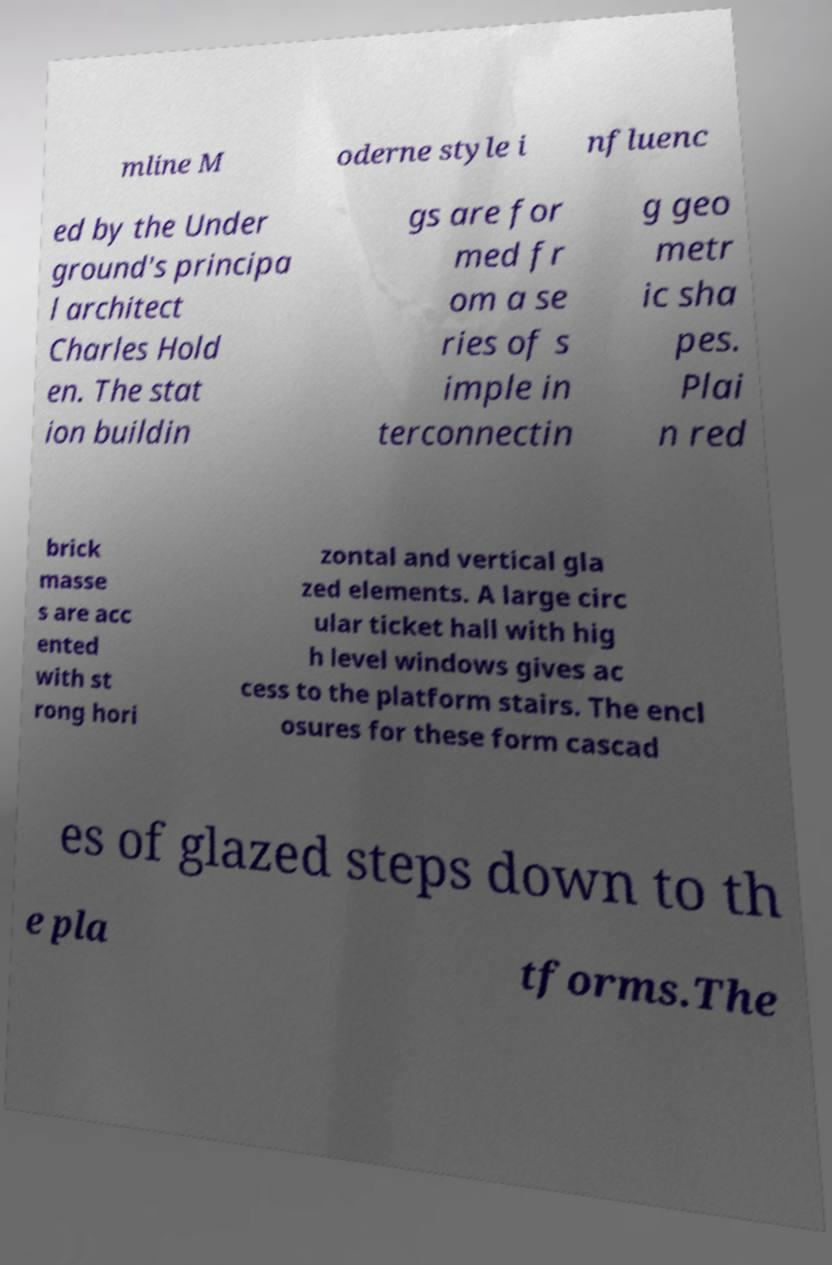What messages or text are displayed in this image? I need them in a readable, typed format. mline M oderne style i nfluenc ed by the Under ground's principa l architect Charles Hold en. The stat ion buildin gs are for med fr om a se ries of s imple in terconnectin g geo metr ic sha pes. Plai n red brick masse s are acc ented with st rong hori zontal and vertical gla zed elements. A large circ ular ticket hall with hig h level windows gives ac cess to the platform stairs. The encl osures for these form cascad es of glazed steps down to th e pla tforms.The 